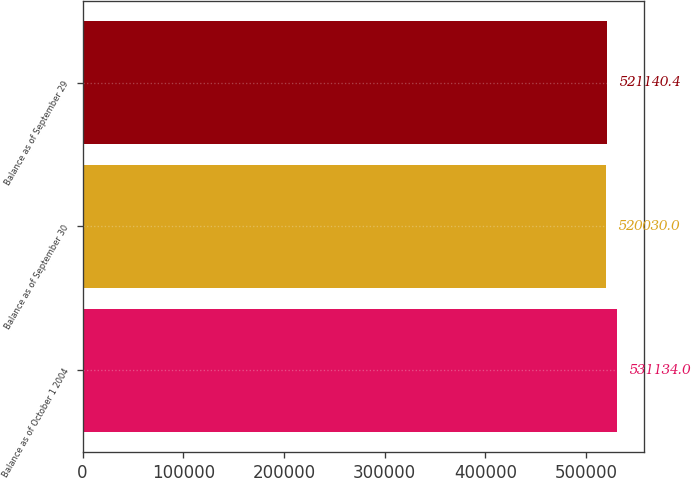Convert chart to OTSL. <chart><loc_0><loc_0><loc_500><loc_500><bar_chart><fcel>Balance as of October 1 2004<fcel>Balance as of September 30<fcel>Balance as of September 29<nl><fcel>531134<fcel>520030<fcel>521140<nl></chart> 